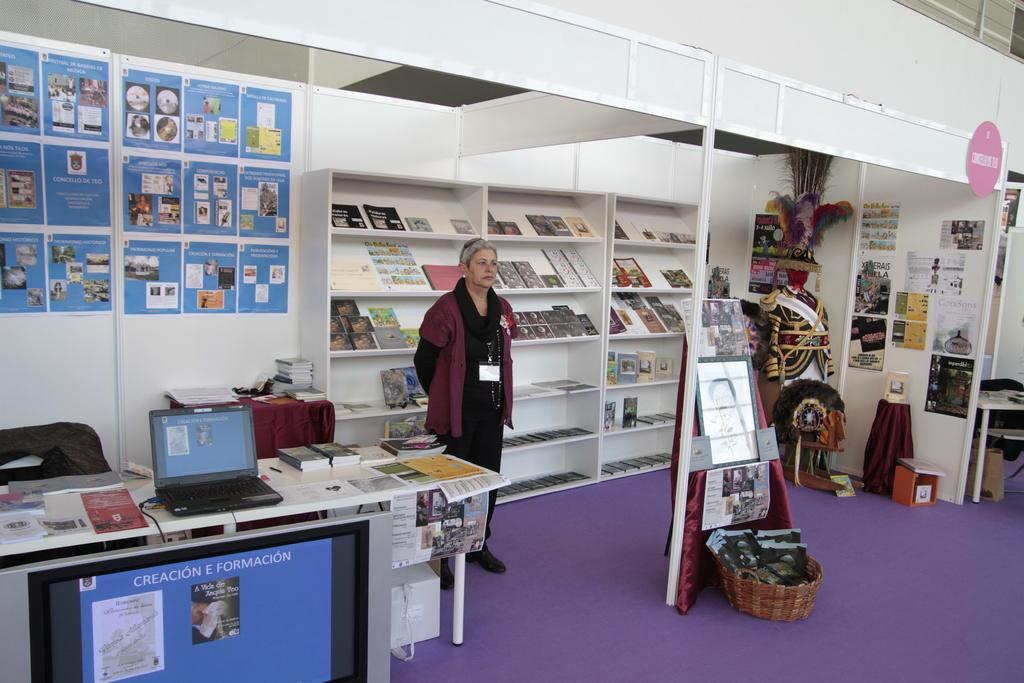What is the main subject in the image? There is a woman standing in the image. What objects are on the table in the image? There are books, a laptop, and papers on the table. What can be seen in the background of the image? There are shelves in the background of the image. What type of string is being used to balance the map in the image? There is no map or string present in the image. 